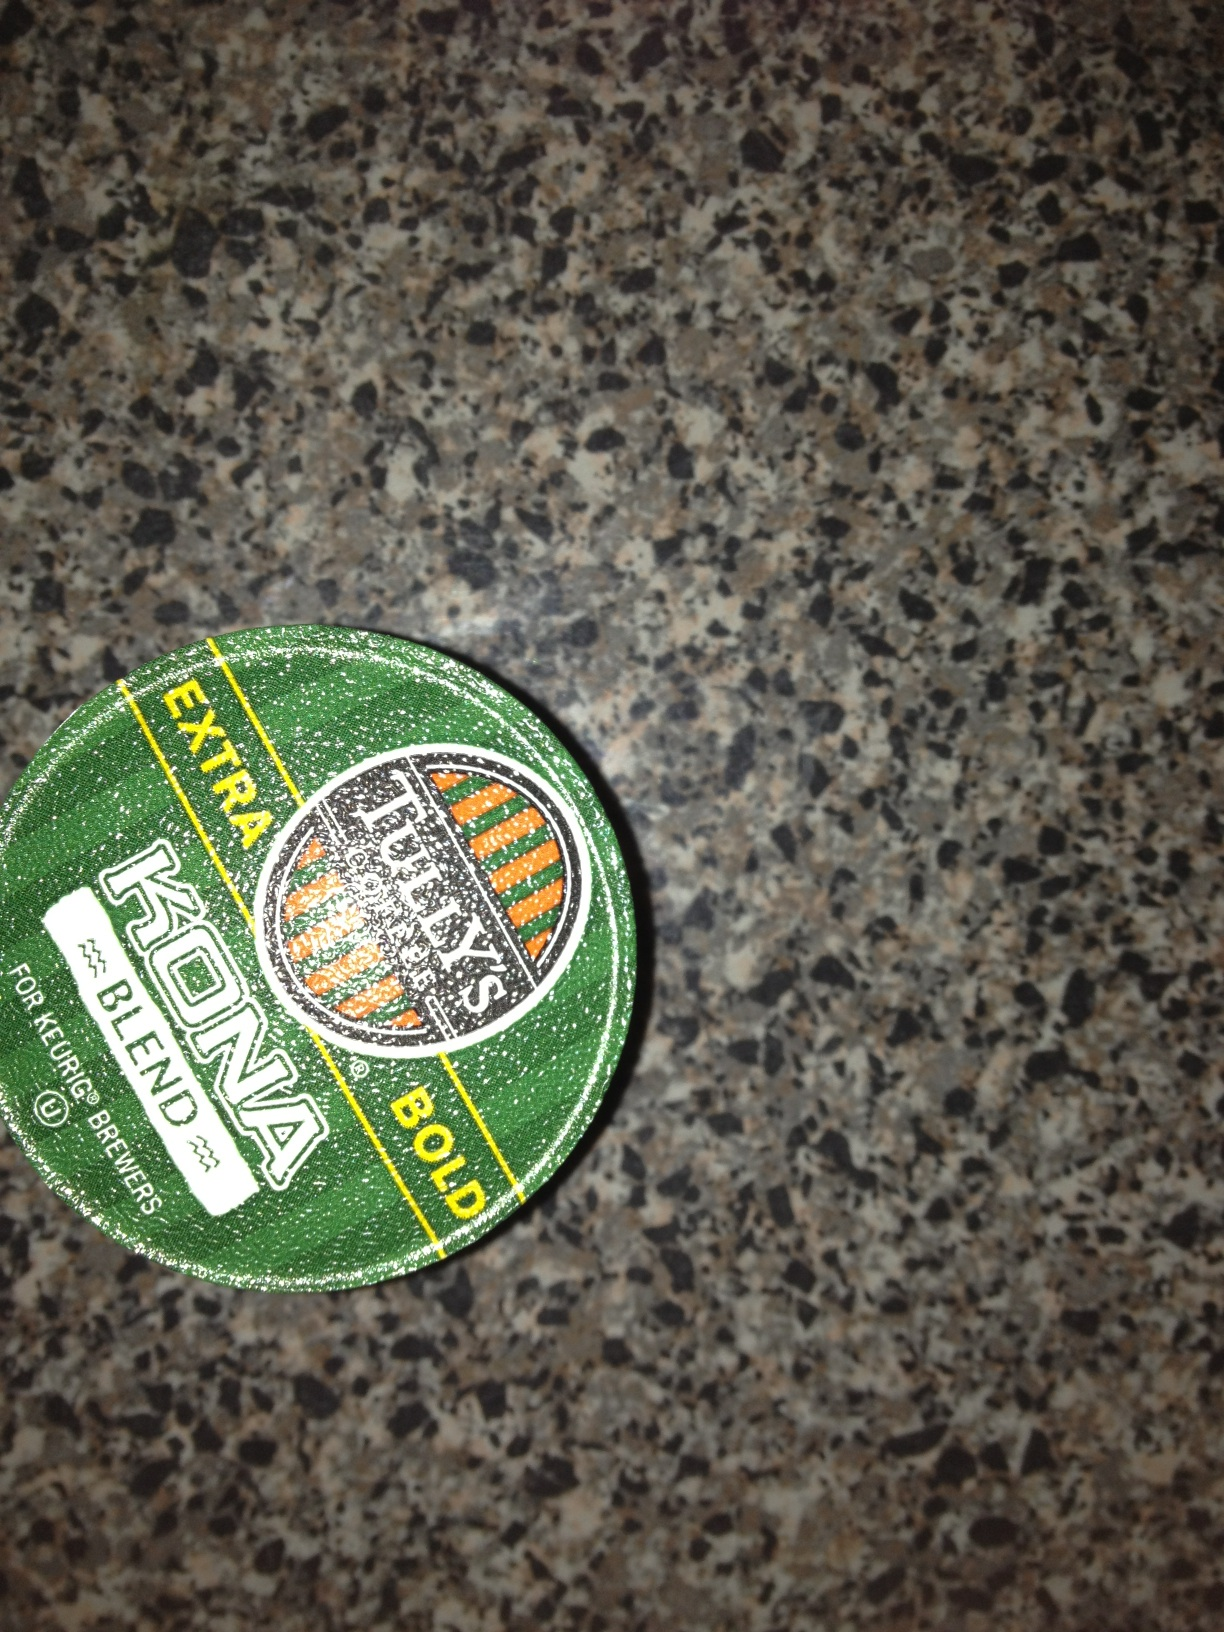What kind of coffee is this? from Vizwiz tullys extra bold kona blend 